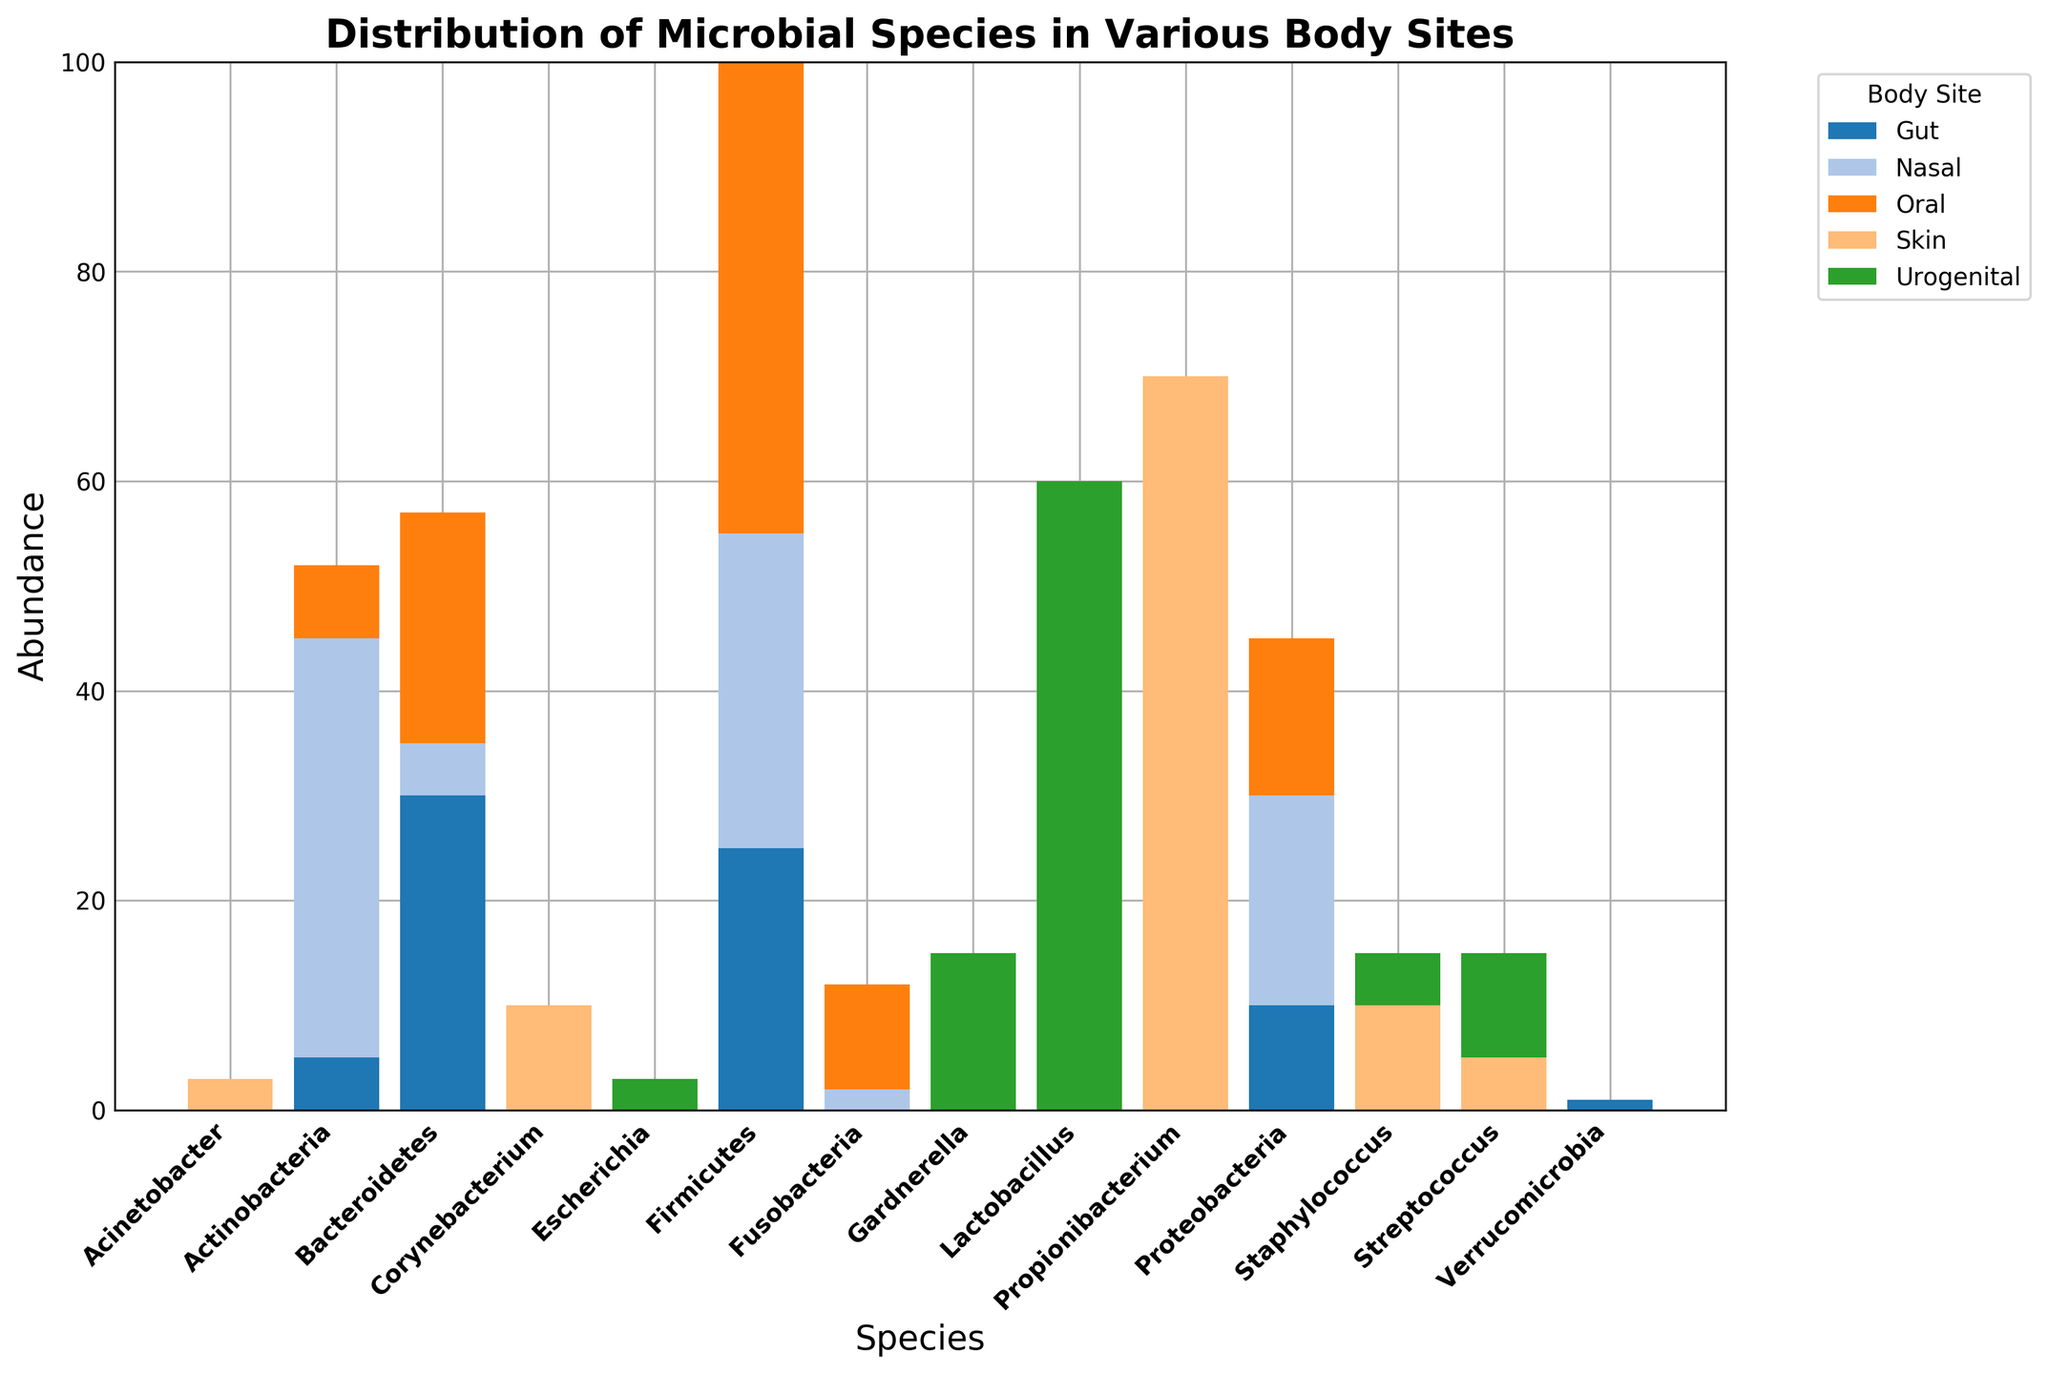Which body site has the highest abundance of Propionibacterium? We need to look for the bar corresponding to Propionibacterium and identify the tallest one. The highest bar for Propionibacterium is clearly from the Skin site.
Answer: Skin Which species has the highest overall abundance across all body sites? We need to find the species with the tallest total bar stacked across all body sites. Summing up the heights for each species, Propionibacterium on Skin is the highest with an abundance of 70.
Answer: Propionibacterium Which species is more abundant in the Gut: Bacteroidetes or Firmicutes? We compare the heights of the bars for Bacteroidetes and Firmicutes in the Gut section. The Bacteroidetes bar is 30, and the Firmicutes bar is 25, so Bacteroidetes is more abundant.
Answer: Bacteroidetes What is the combined abundance of Firmicutes across all body sites? The Firmicutes abundance bars in each body site are 25 (Gut), 45 (Oral), 30 (Nasal), and 0 (Urogenital), summing to 25 + 45 + 30 + 0 = 100.
Answer: 100 Is the abundance of Lactobacillus in the Urogenital site higher than the abundance of Actinobacteria in the Gut? The height of the Lactobacillus bar in the Urogenital site is 60, while the height of the Actinobacteria bar in the Gut is 5. Thus, Lactobacillus is higher in the Urogenital site.
Answer: Yes Which body site has the most diverse microbial profile, considering the number of species present? We count the number of different species bars for each body site. Gut, Skin, Oral, Nasal, and Urogenital have 5, 5, 5, 5, and 5 species respectively. All sites have the same diversity in terms of the number of species.
Answer: All equal What is the relative abundance of Proteobacteria in the Nasal site compared to its abundance in the Oral site? Proteobacteria's abundance in Nasal is 20, and in Oral is 15. The relative abundance is calculated by dividing 20 by 15, giving approximately 1.33.
Answer: 1.33 What is the total abundance of all microbial species in the Oral site? We sum the abundance of all species in the Oral site: 45 (Firmicutes) + 22 (Bacteroidetes) + 15 (Proteobacteria) + 10 (Fusobacteria) + 7 (Actinobacteria) = 99.
Answer: 99 